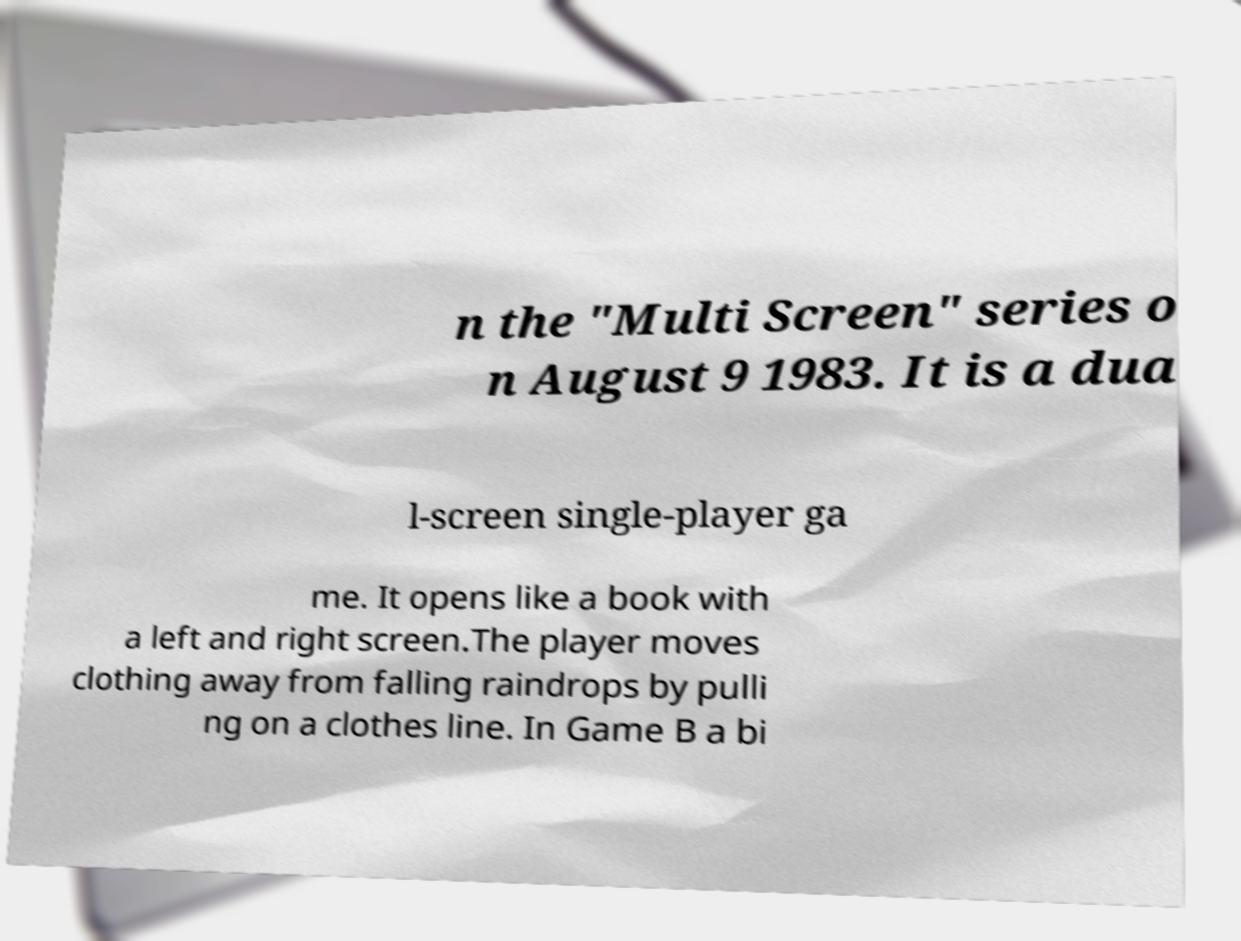For documentation purposes, I need the text within this image transcribed. Could you provide that? n the "Multi Screen" series o n August 9 1983. It is a dua l-screen single-player ga me. It opens like a book with a left and right screen.The player moves clothing away from falling raindrops by pulli ng on a clothes line. In Game B a bi 